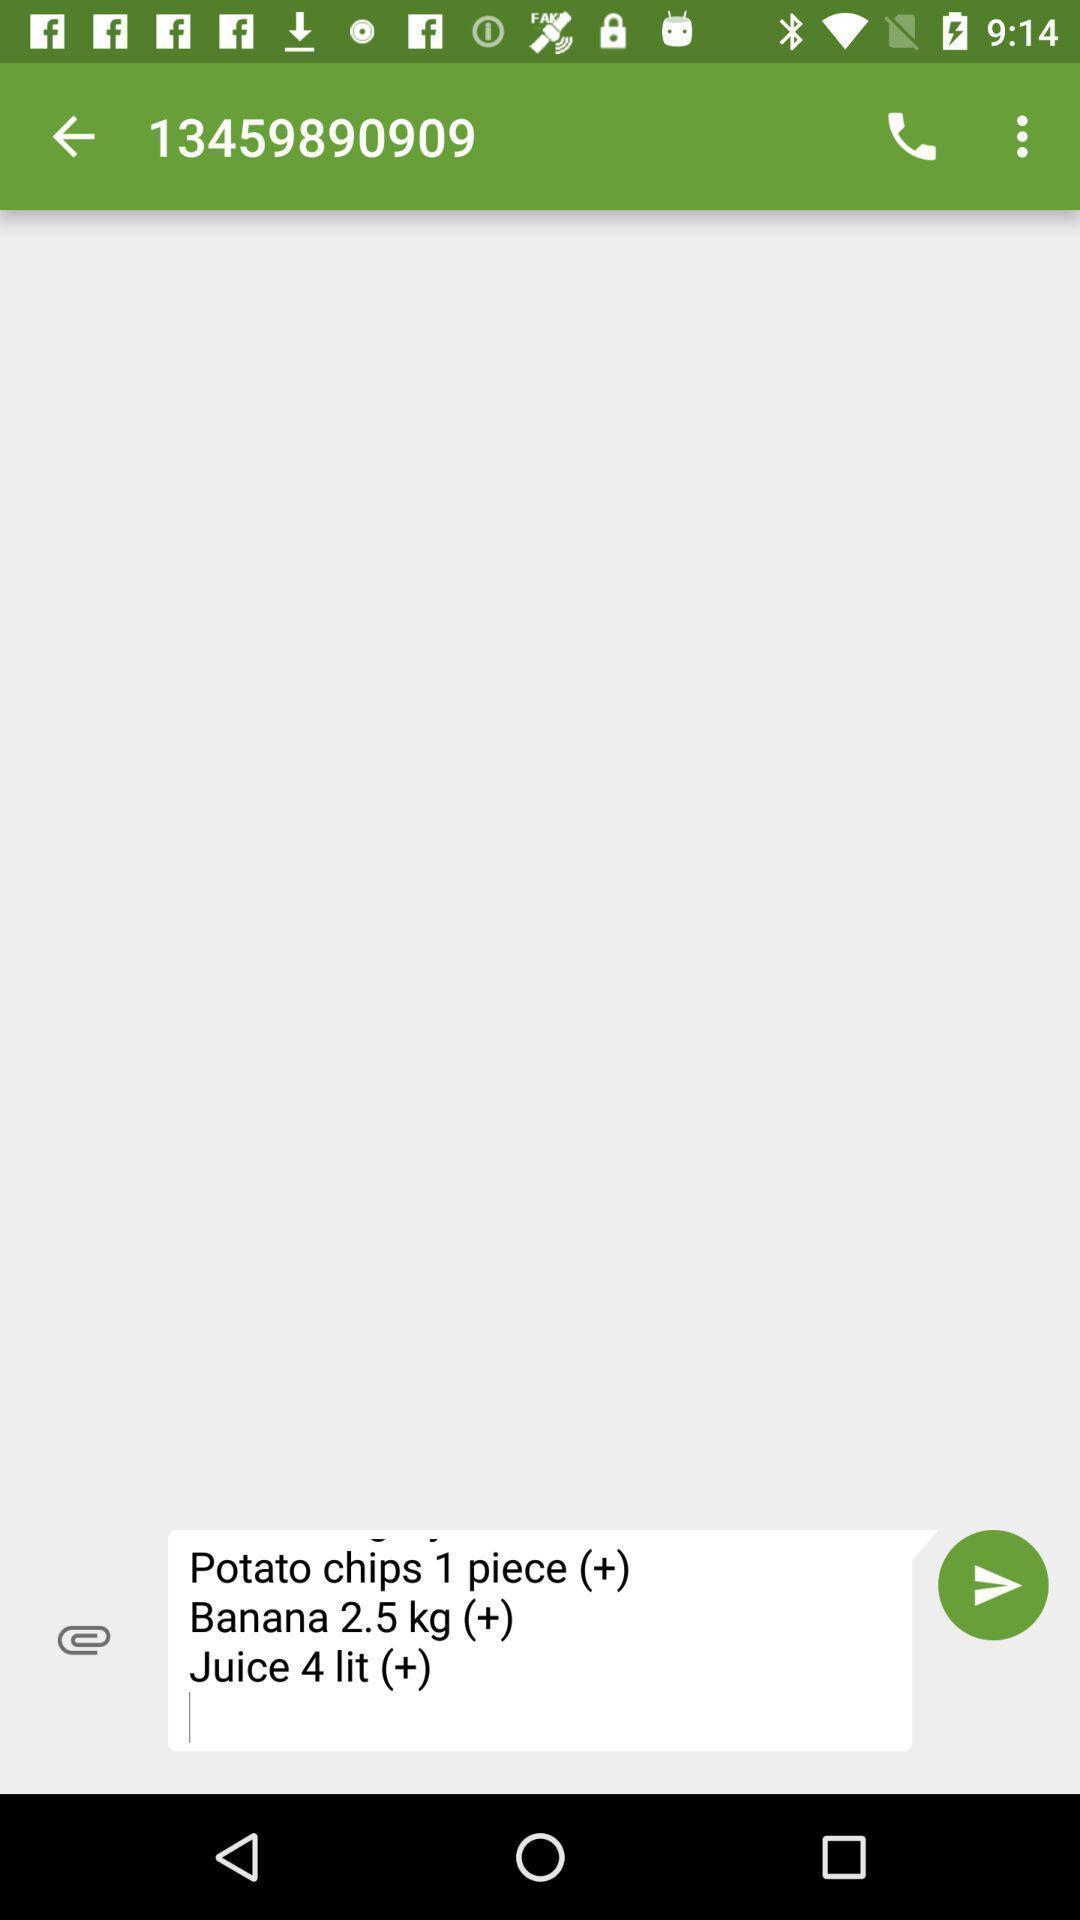Give me a summary of this screen capture. Screen displaying the chat page. 